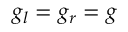Convert formula to latex. <formula><loc_0><loc_0><loc_500><loc_500>g _ { l } = g _ { r } = g</formula> 